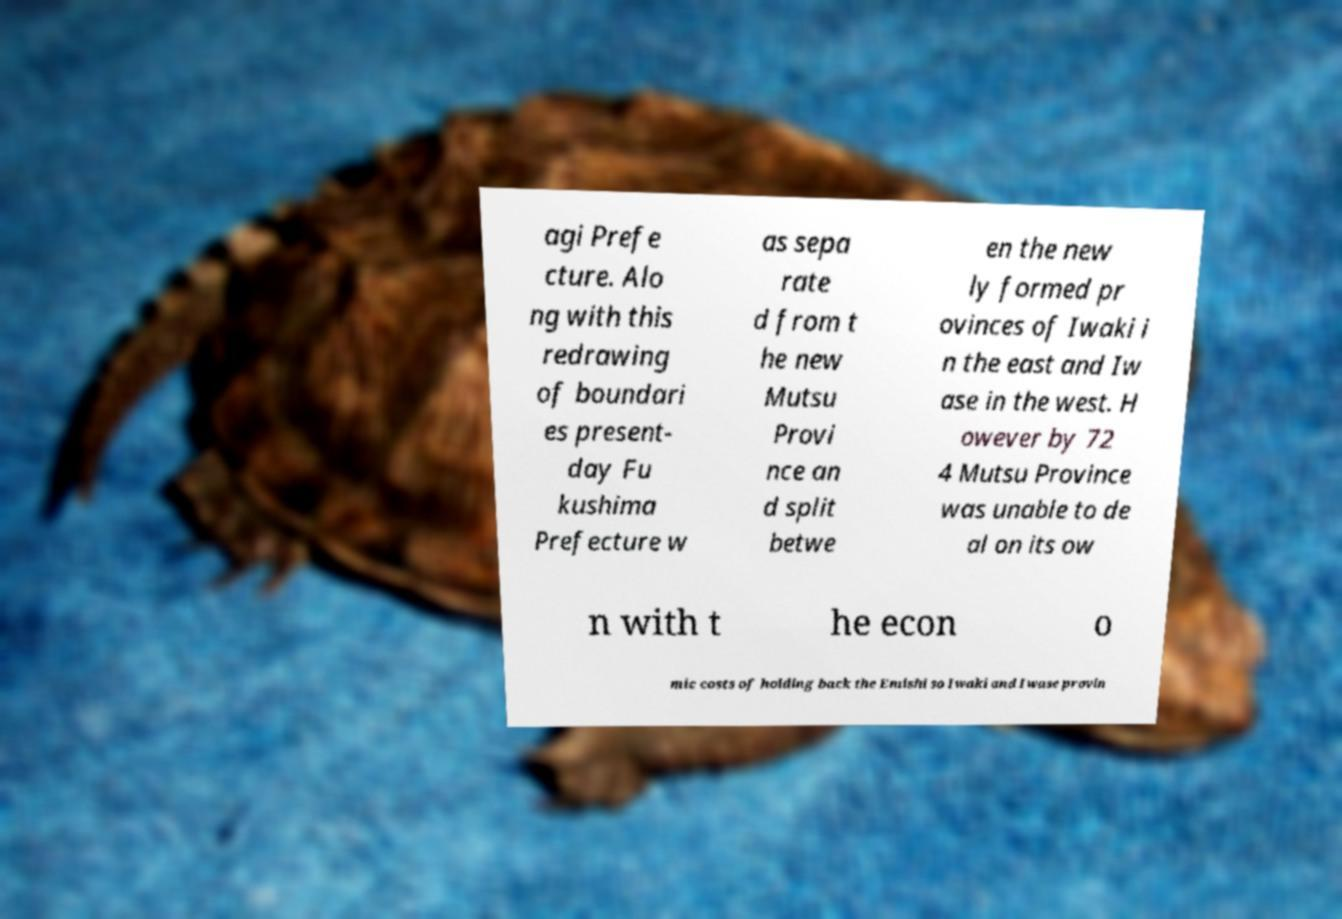There's text embedded in this image that I need extracted. Can you transcribe it verbatim? agi Prefe cture. Alo ng with this redrawing of boundari es present- day Fu kushima Prefecture w as sepa rate d from t he new Mutsu Provi nce an d split betwe en the new ly formed pr ovinces of Iwaki i n the east and Iw ase in the west. H owever by 72 4 Mutsu Province was unable to de al on its ow n with t he econ o mic costs of holding back the Emishi so Iwaki and Iwase provin 